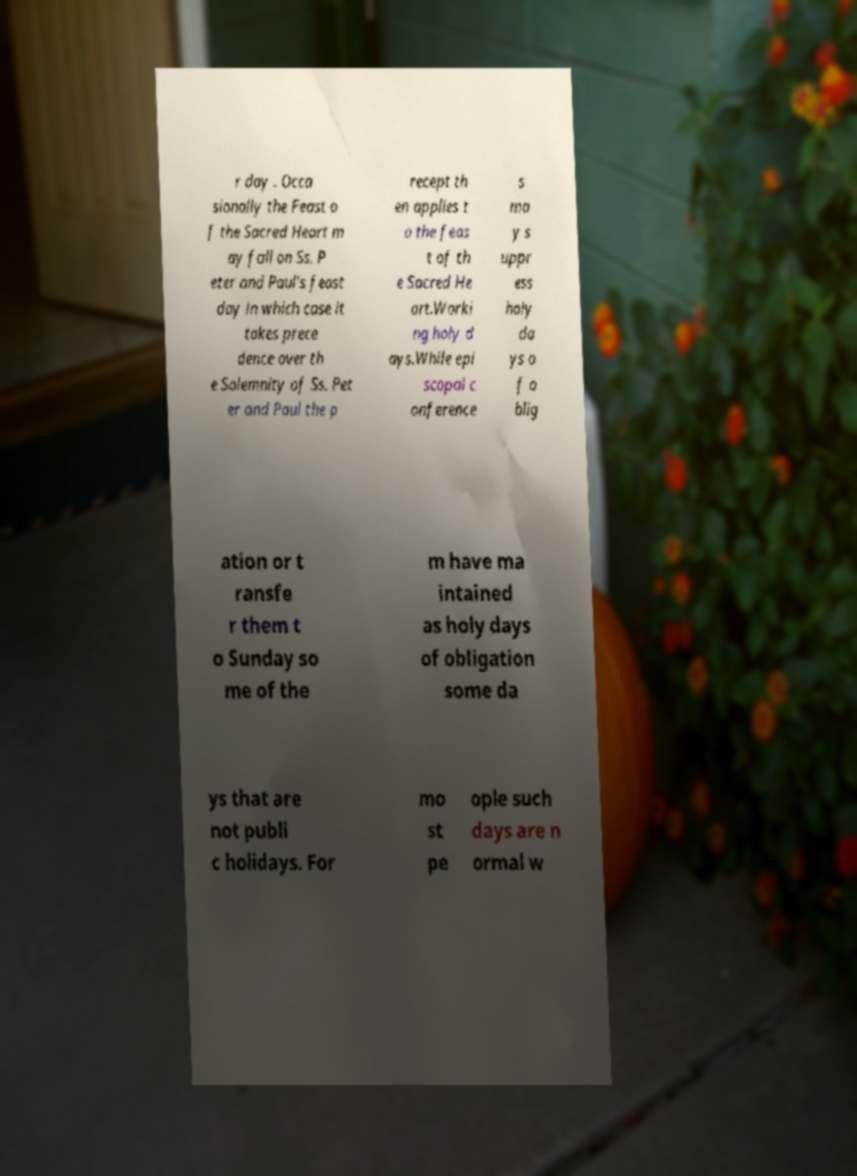Please identify and transcribe the text found in this image. r day . Occa sionally the Feast o f the Sacred Heart m ay fall on Ss. P eter and Paul's feast day in which case it takes prece dence over th e Solemnity of Ss. Pet er and Paul the p recept th en applies t o the feas t of th e Sacred He art.Worki ng holy d ays.While epi scopal c onference s ma y s uppr ess holy da ys o f o blig ation or t ransfe r them t o Sunday so me of the m have ma intained as holy days of obligation some da ys that are not publi c holidays. For mo st pe ople such days are n ormal w 